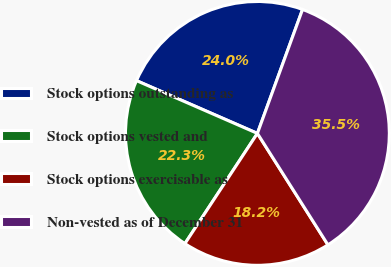Convert chart to OTSL. <chart><loc_0><loc_0><loc_500><loc_500><pie_chart><fcel>Stock options outstanding as<fcel>Stock options vested and<fcel>Stock options exercisable as<fcel>Non-vested as of December 31<nl><fcel>24.01%<fcel>22.29%<fcel>18.24%<fcel>35.46%<nl></chart> 